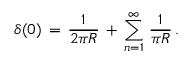<formula> <loc_0><loc_0><loc_500><loc_500>\delta ( 0 ) \, = \, \frac { 1 } { 2 \pi R } \, + \, \sum _ { n = 1 } ^ { \infty } \, \frac { 1 } { \pi R } \, .</formula> 